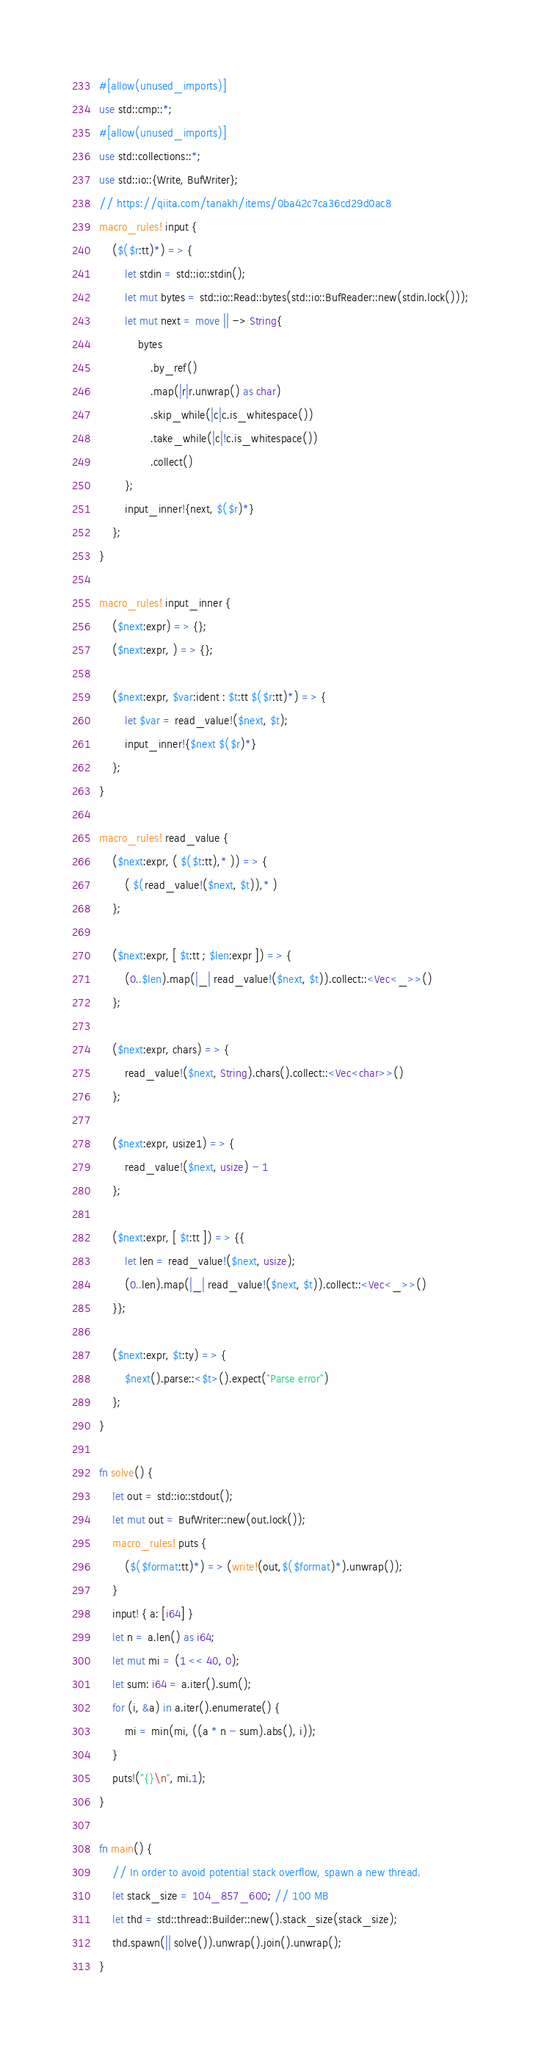<code> <loc_0><loc_0><loc_500><loc_500><_Rust_>#[allow(unused_imports)]
use std::cmp::*;
#[allow(unused_imports)]
use std::collections::*;
use std::io::{Write, BufWriter};
// https://qiita.com/tanakh/items/0ba42c7ca36cd29d0ac8
macro_rules! input {
    ($($r:tt)*) => {
        let stdin = std::io::stdin();
        let mut bytes = std::io::Read::bytes(std::io::BufReader::new(stdin.lock()));
        let mut next = move || -> String{
            bytes
                .by_ref()
                .map(|r|r.unwrap() as char)
                .skip_while(|c|c.is_whitespace())
                .take_while(|c|!c.is_whitespace())
                .collect()
        };
        input_inner!{next, $($r)*}
    };
}

macro_rules! input_inner {
    ($next:expr) => {};
    ($next:expr, ) => {};

    ($next:expr, $var:ident : $t:tt $($r:tt)*) => {
        let $var = read_value!($next, $t);
        input_inner!{$next $($r)*}
    };
}

macro_rules! read_value {
    ($next:expr, ( $($t:tt),* )) => {
        ( $(read_value!($next, $t)),* )
    };

    ($next:expr, [ $t:tt ; $len:expr ]) => {
        (0..$len).map(|_| read_value!($next, $t)).collect::<Vec<_>>()
    };

    ($next:expr, chars) => {
        read_value!($next, String).chars().collect::<Vec<char>>()
    };

    ($next:expr, usize1) => {
        read_value!($next, usize) - 1
    };

    ($next:expr, [ $t:tt ]) => {{
        let len = read_value!($next, usize);
        (0..len).map(|_| read_value!($next, $t)).collect::<Vec<_>>()
    }};

    ($next:expr, $t:ty) => {
        $next().parse::<$t>().expect("Parse error")
    };
}

fn solve() {
    let out = std::io::stdout();
    let mut out = BufWriter::new(out.lock());
    macro_rules! puts {
        ($($format:tt)*) => (write!(out,$($format)*).unwrap());
    }
    input! { a: [i64] }
    let n = a.len() as i64;
    let mut mi = (1 << 40, 0);
    let sum: i64 = a.iter().sum();
    for (i, &a) in a.iter().enumerate() {
        mi = min(mi, ((a * n - sum).abs(), i));
    }
    puts!("{}\n", mi.1);
}

fn main() {
    // In order to avoid potential stack overflow, spawn a new thread.
    let stack_size = 104_857_600; // 100 MB
    let thd = std::thread::Builder::new().stack_size(stack_size);
    thd.spawn(|| solve()).unwrap().join().unwrap();
}
</code> 